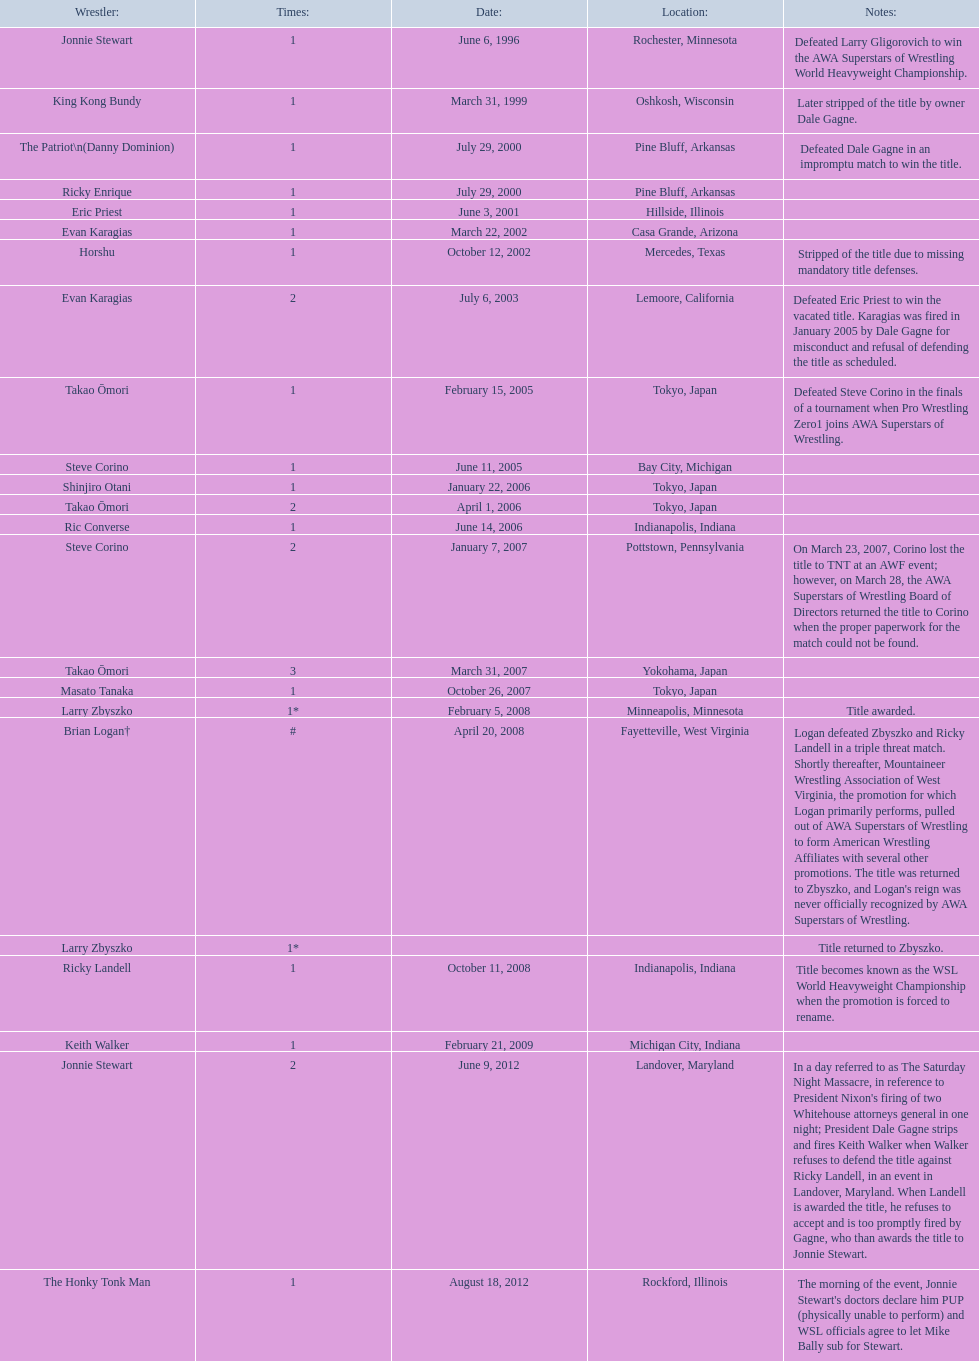Where are the title holders from? Rochester, Minnesota, Oshkosh, Wisconsin, Pine Bluff, Arkansas, Pine Bluff, Arkansas, Hillside, Illinois, Casa Grande, Arizona, Mercedes, Texas, Lemoore, California, Tokyo, Japan, Bay City, Michigan, Tokyo, Japan, Tokyo, Japan, Indianapolis, Indiana, Pottstown, Pennsylvania, Yokohama, Japan, Tokyo, Japan, Minneapolis, Minnesota, Fayetteville, West Virginia, , Indianapolis, Indiana, Michigan City, Indiana, Landover, Maryland, Rockford, Illinois. Who is the title holder from texas? Horshu. 